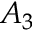<formula> <loc_0><loc_0><loc_500><loc_500>A _ { 3 }</formula> 